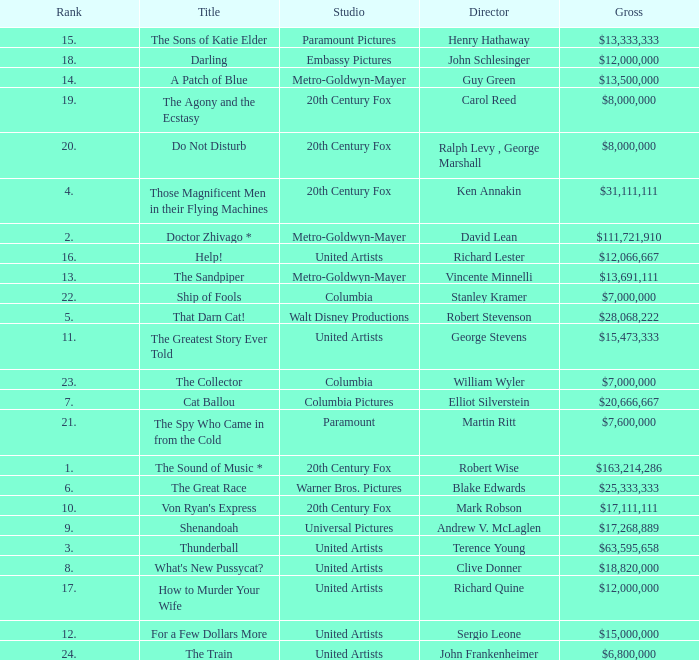What is Title, when Studio is "Embassy Pictures"? Darling. 